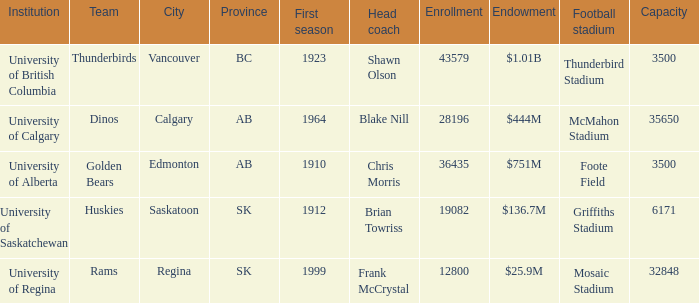How many cities have an enrollment of 19082? 1.0. 